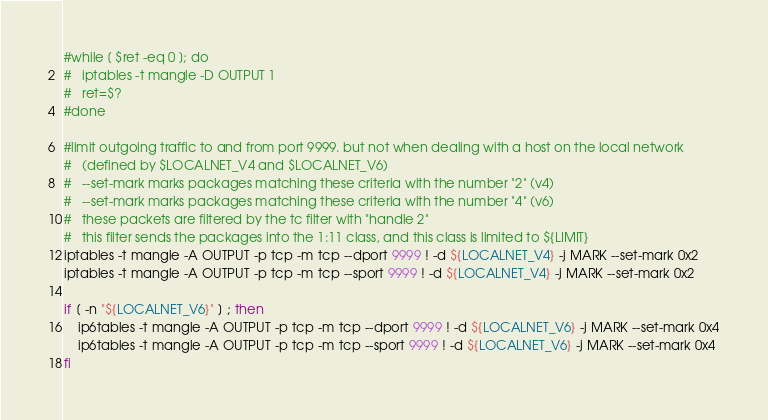<code> <loc_0><loc_0><loc_500><loc_500><_Bash_>#while [ $ret -eq 0 ]; do
#	iptables -t mangle -D OUTPUT 1
#	ret=$?
#done

#limit outgoing traffic to and from port 9999. but not when dealing with a host on the local network
#	(defined by $LOCALNET_V4 and $LOCALNET_V6)
#	--set-mark marks packages matching these criteria with the number "2" (v4)
#	--set-mark marks packages matching these criteria with the number "4" (v6)
#	these packets are filtered by the tc filter with "handle 2"
#	this filter sends the packages into the 1:11 class, and this class is limited to ${LIMIT}
iptables -t mangle -A OUTPUT -p tcp -m tcp --dport 9999 ! -d ${LOCALNET_V4} -j MARK --set-mark 0x2
iptables -t mangle -A OUTPUT -p tcp -m tcp --sport 9999 ! -d ${LOCALNET_V4} -j MARK --set-mark 0x2

if [ -n "${LOCALNET_V6}" ] ; then
	ip6tables -t mangle -A OUTPUT -p tcp -m tcp --dport 9999 ! -d ${LOCALNET_V6} -j MARK --set-mark 0x4
	ip6tables -t mangle -A OUTPUT -p tcp -m tcp --sport 9999 ! -d ${LOCALNET_V6} -j MARK --set-mark 0x4
fi
</code> 